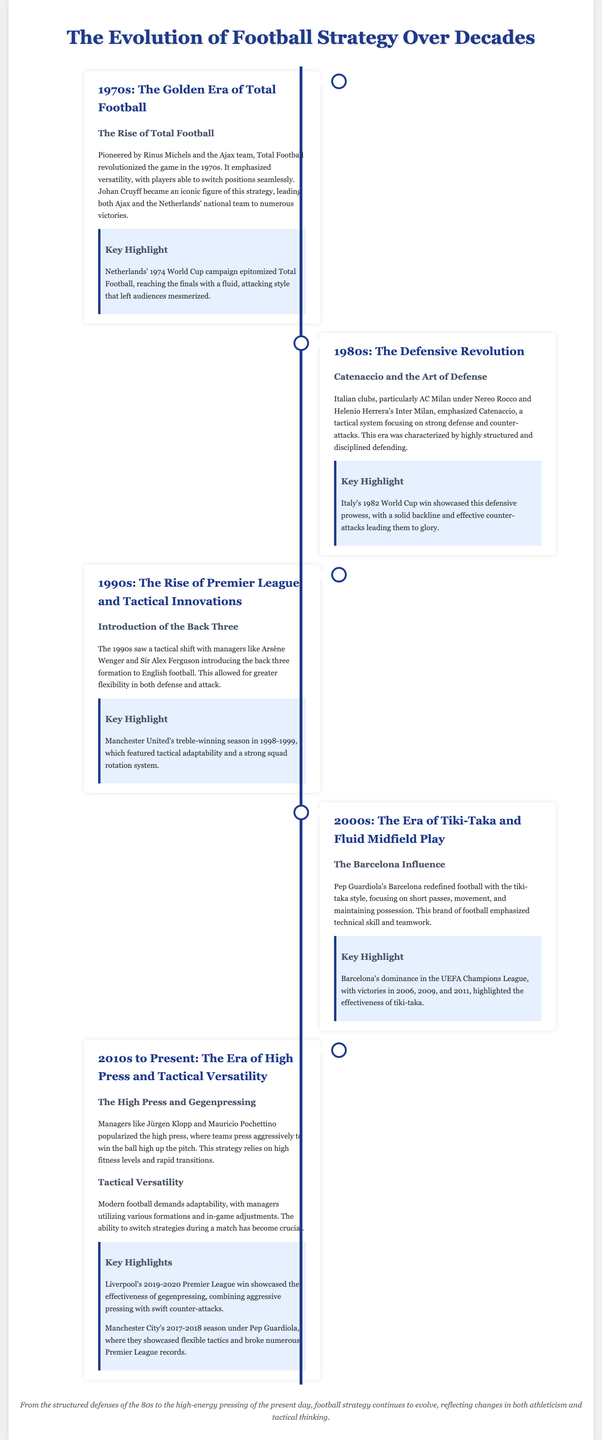What was the prominent football strategy in the 1970s? The infographic states that Total Football was the prominent strategy during the 1970s.
Answer: Total Football Who was a key figure in the development of Total Football? The infographic mentions Johan Cruyff as an iconic figure in Total Football.
Answer: Johan Cruyff What tactical system did Italian clubs emphasize in the 1980s? The infographic details that the tactical system emphasized was Catenaccio.
Answer: Catenaccio Which football club is associated with the introduction of the back three in the 1990s? The infographic highlights Arsène Wenger and Sir Alex Ferguson's contributions, which include Manchester United.
Answer: Manchester United What style did Pep Guardiola's Barcelona popularize in the 2000s? The infographic specifies that Pep Guardiola’s Barcelona popularized the tiki-taka style.
Answer: Tiki-taka What key style is featured in the 2010s to present-day football strategies? The infographic notes that high press and gegenpressing are key styles featured in modern football.
Answer: High press Which team showcased the effectiveness of gegenpressing in the 2019-2020 season? Liverpool is mentioned as the team that showcased the effectiveness of gegenpressing during that season.
Answer: Liverpool What tournament did Italy win in 1982, reflecting their defensive prowess? The infographic indicates that Italy won the World Cup in 1982.
Answer: World Cup How many UEFA Champions League titles did Barcelona win in the 2000s? The infographic states that Barcelona won three titles in the UEFA Champions League during the 2000s.
Answer: Three 